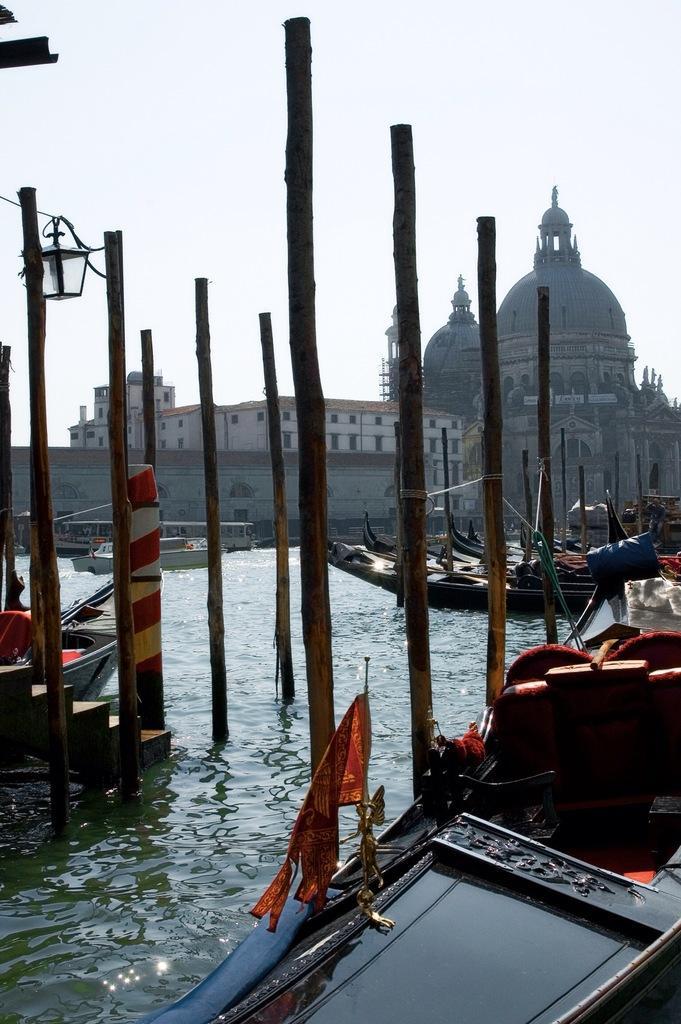How would you summarize this image in a sentence or two? In this image we can see some boats and wooden poles in a water body. We can also see a street lamp and the flag. On the backside we can see some buildings with windows and the sky which looks cloudy. 